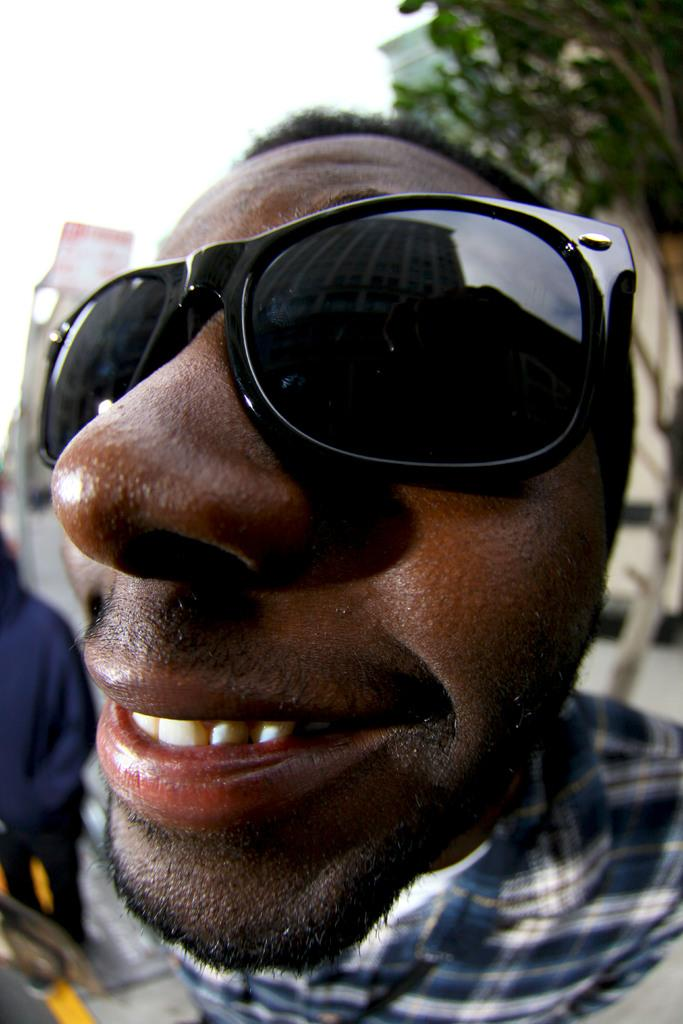What is the main subject of the picture? The main subject of the picture is a man. What is the man wearing on his face? The man is wearing goggles. What expression does the man have? The man is smiling. What can be seen in the background of the picture? There is a tree, buildings, and people in the background of the picture. What type of bean is the man holding in the picture? There is no bean present in the image; the man is wearing goggles and smiling. What color is the cap the man is wearing in the picture? There is no cap present in the image; the man is wearing goggles and smiling. 